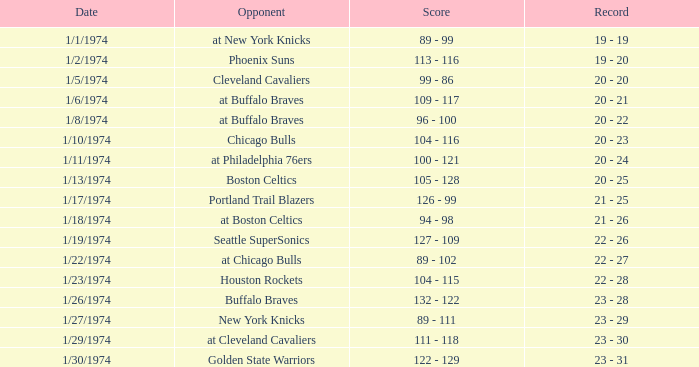Write the full table. {'header': ['Date', 'Opponent', 'Score', 'Record'], 'rows': [['1/1/1974', 'at New York Knicks', '89 - 99', '19 - 19'], ['1/2/1974', 'Phoenix Suns', '113 - 116', '19 - 20'], ['1/5/1974', 'Cleveland Cavaliers', '99 - 86', '20 - 20'], ['1/6/1974', 'at Buffalo Braves', '109 - 117', '20 - 21'], ['1/8/1974', 'at Buffalo Braves', '96 - 100', '20 - 22'], ['1/10/1974', 'Chicago Bulls', '104 - 116', '20 - 23'], ['1/11/1974', 'at Philadelphia 76ers', '100 - 121', '20 - 24'], ['1/13/1974', 'Boston Celtics', '105 - 128', '20 - 25'], ['1/17/1974', 'Portland Trail Blazers', '126 - 99', '21 - 25'], ['1/18/1974', 'at Boston Celtics', '94 - 98', '21 - 26'], ['1/19/1974', 'Seattle SuperSonics', '127 - 109', '22 - 26'], ['1/22/1974', 'at Chicago Bulls', '89 - 102', '22 - 27'], ['1/23/1974', 'Houston Rockets', '104 - 115', '22 - 28'], ['1/26/1974', 'Buffalo Braves', '132 - 122', '23 - 28'], ['1/27/1974', 'New York Knicks', '89 - 111', '23 - 29'], ['1/29/1974', 'at Cleveland Cavaliers', '111 - 118', '23 - 30'], ['1/30/1974', 'Golden State Warriors', '122 - 129', '23 - 31']]} Which competitor took part on 1/13/1974? Boston Celtics. 